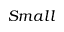Convert formula to latex. <formula><loc_0><loc_0><loc_500><loc_500>S m a l l</formula> 